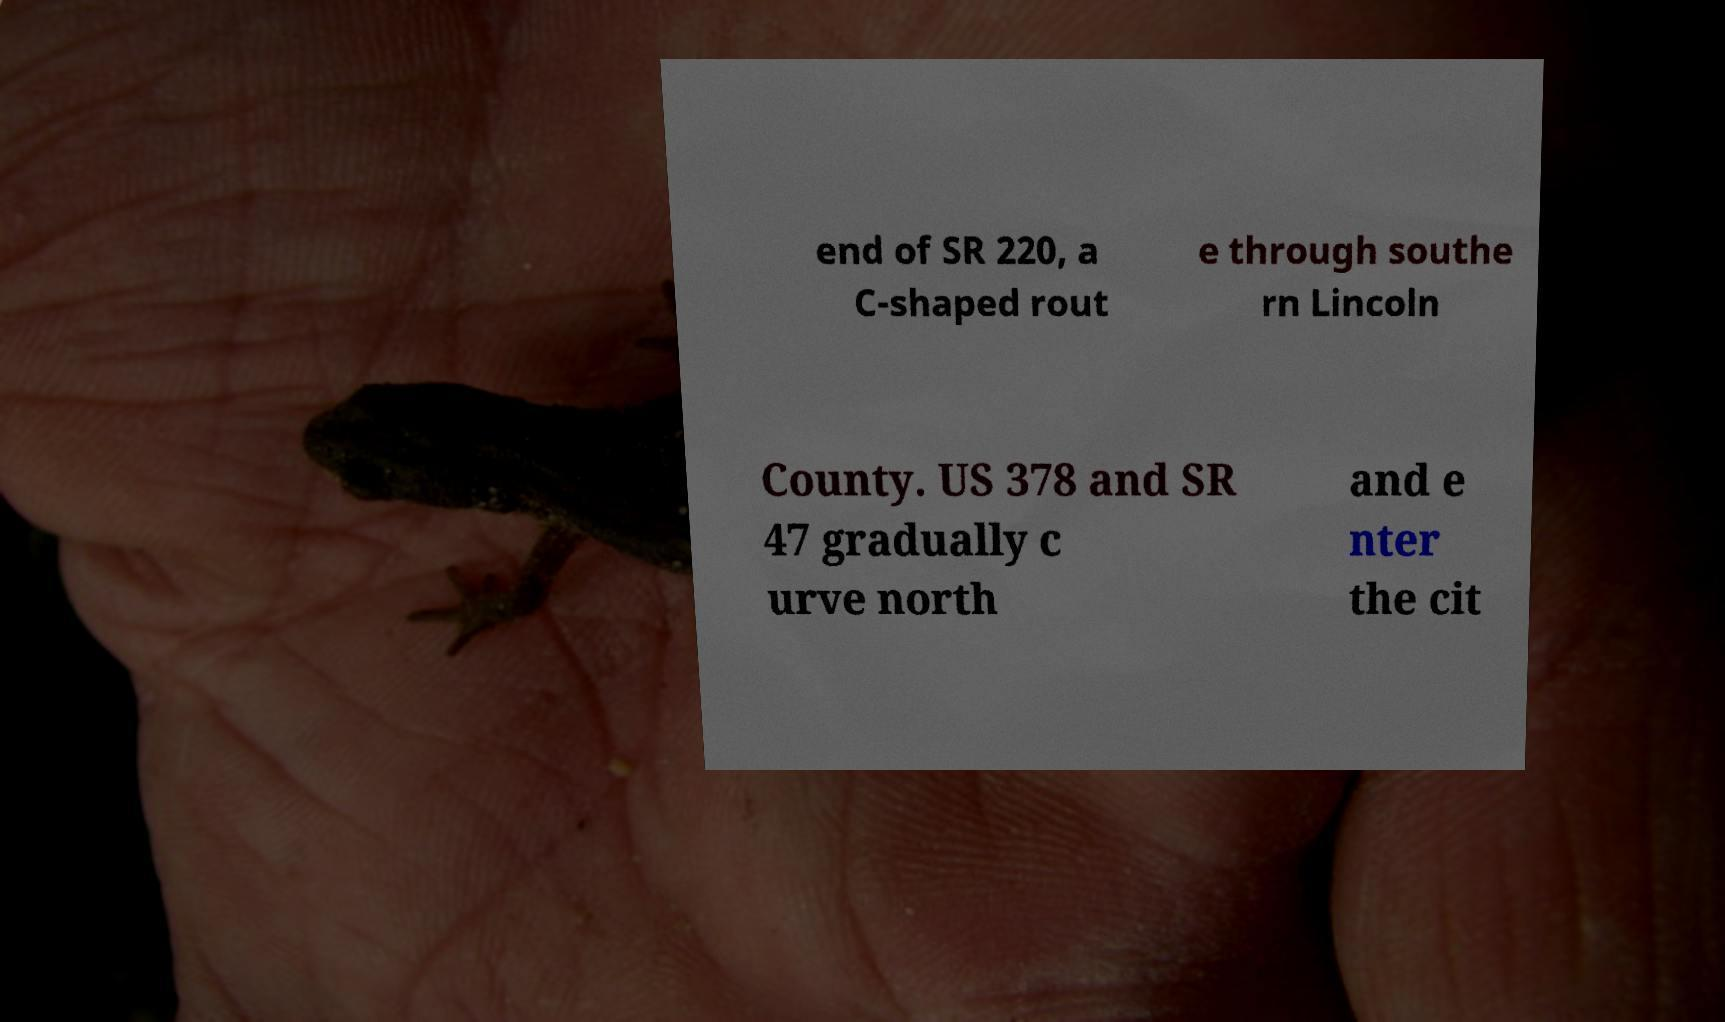I need the written content from this picture converted into text. Can you do that? end of SR 220, a C-shaped rout e through southe rn Lincoln County. US 378 and SR 47 gradually c urve north and e nter the cit 